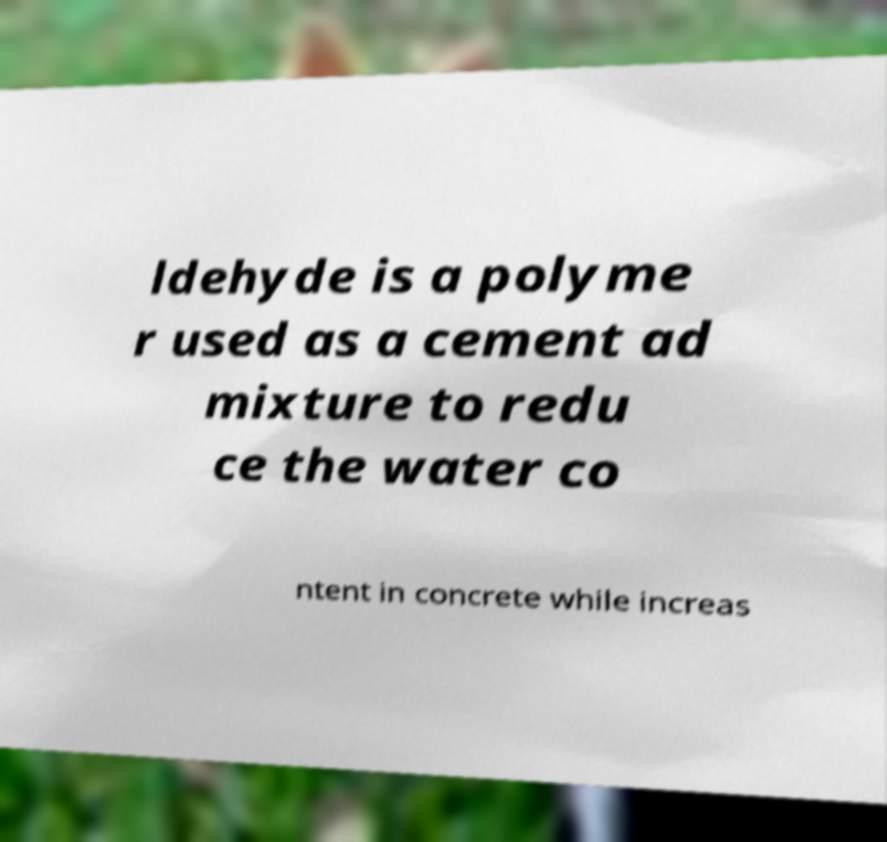Could you assist in decoding the text presented in this image and type it out clearly? ldehyde is a polyme r used as a cement ad mixture to redu ce the water co ntent in concrete while increas 